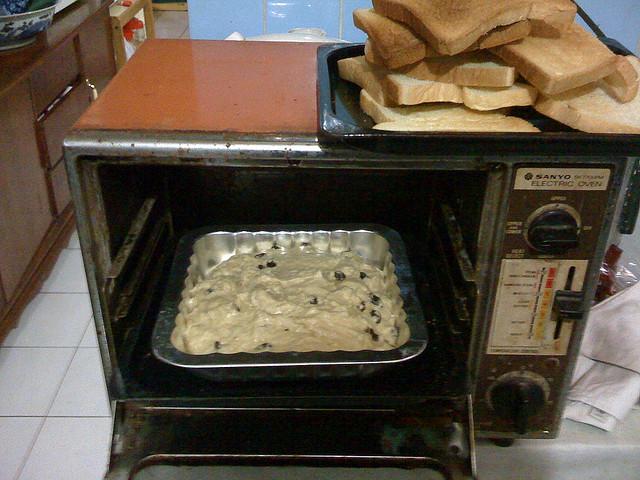What is cooking?
Be succinct. Cake. Is the toast buttered?
Be succinct. No. How many Smokies are been cooked?
Short answer required. 0. What brand is the oven?
Answer briefly. Sanyo. 